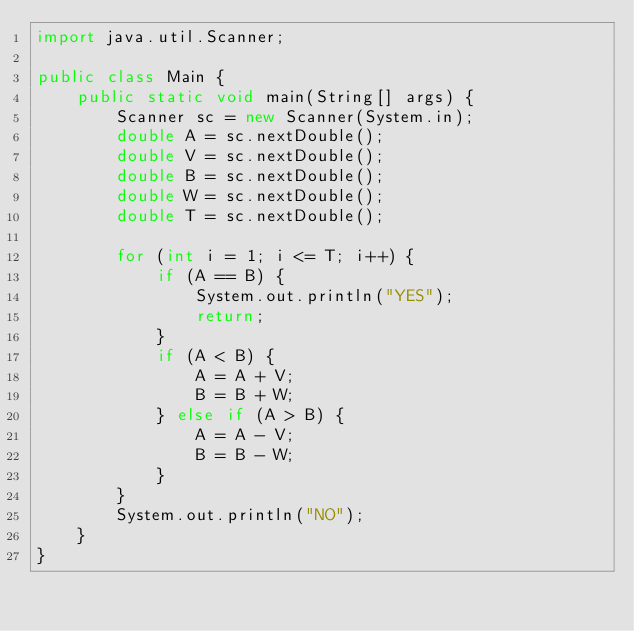<code> <loc_0><loc_0><loc_500><loc_500><_Java_>import java.util.Scanner;

public class Main {
    public static void main(String[] args) {
        Scanner sc = new Scanner(System.in);
        double A = sc.nextDouble();
        double V = sc.nextDouble();
        double B = sc.nextDouble();
        double W = sc.nextDouble();
        double T = sc.nextDouble();

        for (int i = 1; i <= T; i++) {
            if (A == B) {
                System.out.println("YES");
                return;
            }
            if (A < B) {
                A = A + V;
                B = B + W;
            } else if (A > B) {
                A = A - V;
                B = B - W;
            }
        }
        System.out.println("NO");
    }
}</code> 